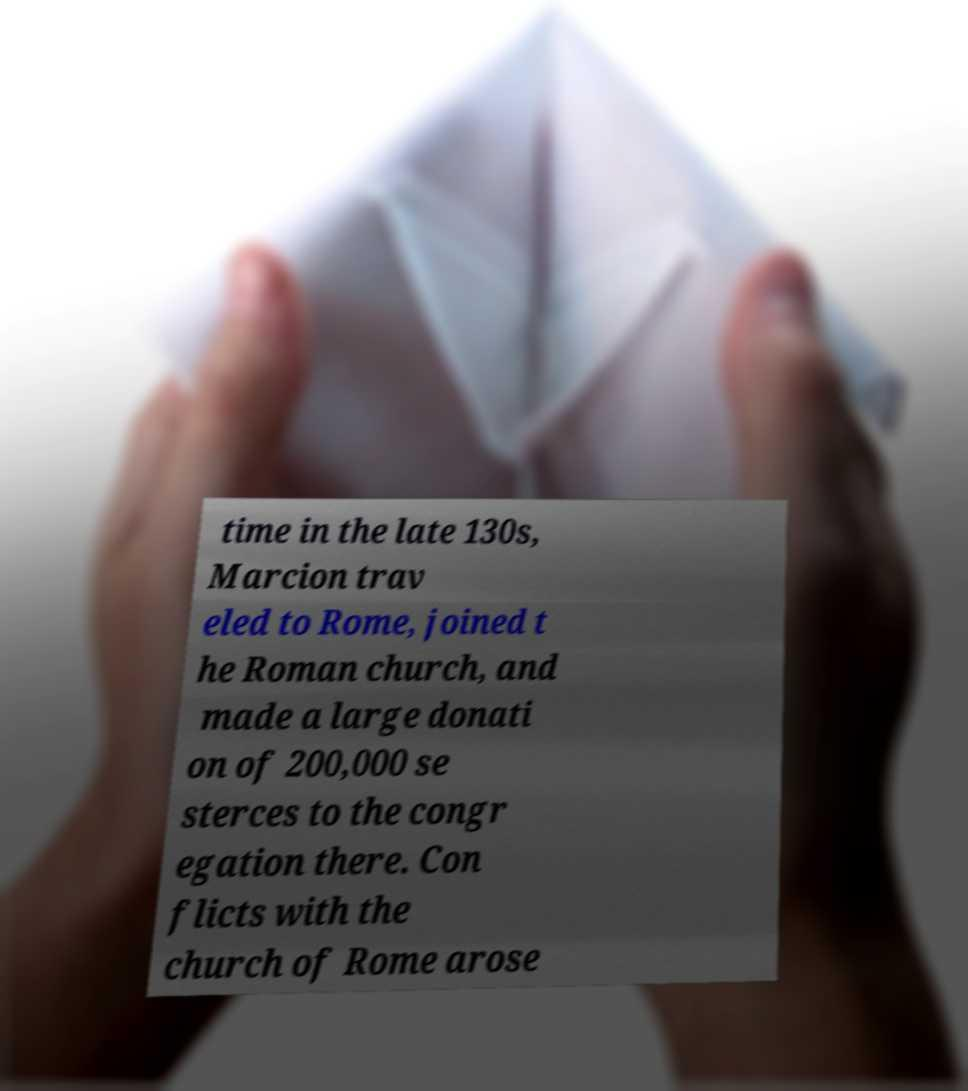Please read and relay the text visible in this image. What does it say? time in the late 130s, Marcion trav eled to Rome, joined t he Roman church, and made a large donati on of 200,000 se sterces to the congr egation there. Con flicts with the church of Rome arose 